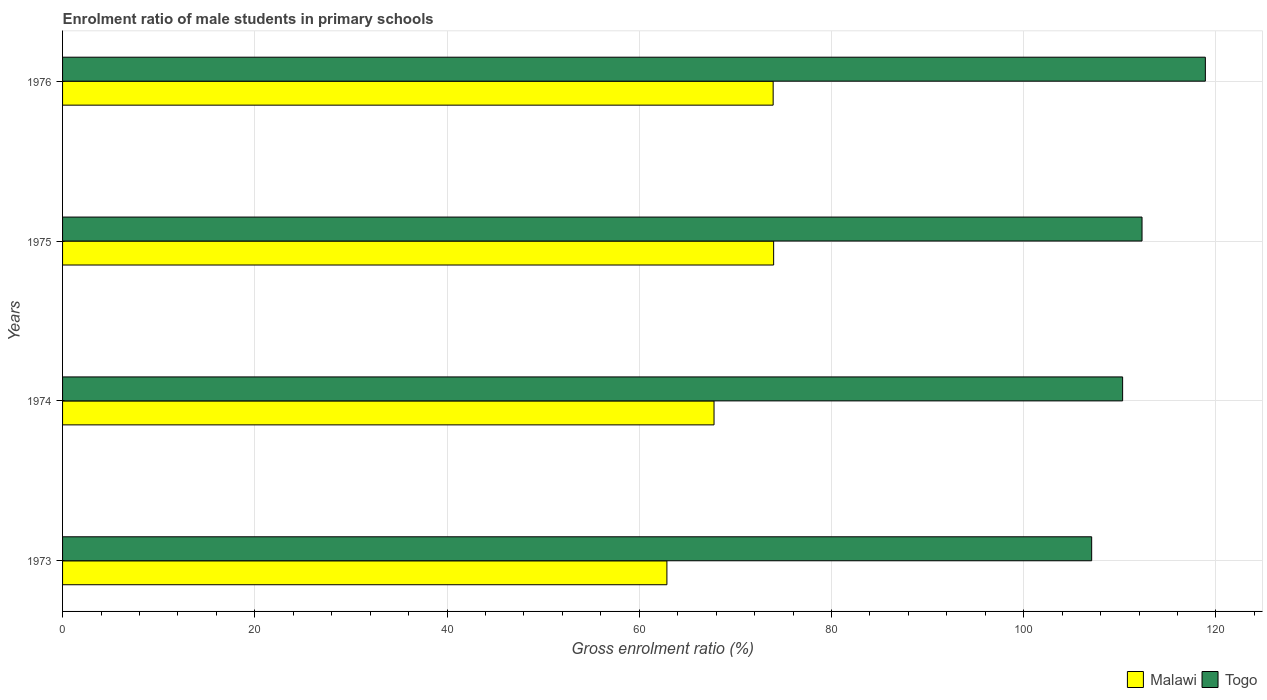Are the number of bars per tick equal to the number of legend labels?
Provide a succinct answer. Yes. Are the number of bars on each tick of the Y-axis equal?
Give a very brief answer. Yes. How many bars are there on the 2nd tick from the bottom?
Offer a very short reply. 2. In how many cases, is the number of bars for a given year not equal to the number of legend labels?
Ensure brevity in your answer.  0. What is the enrolment ratio of male students in primary schools in Malawi in 1975?
Your answer should be compact. 73.98. Across all years, what is the maximum enrolment ratio of male students in primary schools in Togo?
Make the answer very short. 118.9. Across all years, what is the minimum enrolment ratio of male students in primary schools in Malawi?
Your answer should be very brief. 62.88. In which year was the enrolment ratio of male students in primary schools in Malawi maximum?
Offer a very short reply. 1975. What is the total enrolment ratio of male students in primary schools in Togo in the graph?
Your answer should be very brief. 448.56. What is the difference between the enrolment ratio of male students in primary schools in Malawi in 1975 and that in 1976?
Provide a succinct answer. 0.05. What is the difference between the enrolment ratio of male students in primary schools in Togo in 1975 and the enrolment ratio of male students in primary schools in Malawi in 1974?
Offer a terse response. 44.53. What is the average enrolment ratio of male students in primary schools in Togo per year?
Give a very brief answer. 112.14. In the year 1973, what is the difference between the enrolment ratio of male students in primary schools in Togo and enrolment ratio of male students in primary schools in Malawi?
Keep it short and to the point. 44.19. In how many years, is the enrolment ratio of male students in primary schools in Malawi greater than 52 %?
Ensure brevity in your answer.  4. What is the ratio of the enrolment ratio of male students in primary schools in Togo in 1974 to that in 1976?
Offer a terse response. 0.93. Is the enrolment ratio of male students in primary schools in Malawi in 1973 less than that in 1974?
Provide a succinct answer. Yes. Is the difference between the enrolment ratio of male students in primary schools in Togo in 1973 and 1976 greater than the difference between the enrolment ratio of male students in primary schools in Malawi in 1973 and 1976?
Your answer should be compact. No. What is the difference between the highest and the second highest enrolment ratio of male students in primary schools in Malawi?
Offer a very short reply. 0.05. What is the difference between the highest and the lowest enrolment ratio of male students in primary schools in Malawi?
Your answer should be very brief. 11.11. Is the sum of the enrolment ratio of male students in primary schools in Togo in 1973 and 1975 greater than the maximum enrolment ratio of male students in primary schools in Malawi across all years?
Your answer should be very brief. Yes. What does the 2nd bar from the top in 1974 represents?
Provide a short and direct response. Malawi. What does the 1st bar from the bottom in 1976 represents?
Provide a short and direct response. Malawi. How many years are there in the graph?
Offer a terse response. 4. What is the difference between two consecutive major ticks on the X-axis?
Your answer should be very brief. 20. How are the legend labels stacked?
Offer a terse response. Horizontal. What is the title of the graph?
Keep it short and to the point. Enrolment ratio of male students in primary schools. What is the Gross enrolment ratio (%) of Malawi in 1973?
Ensure brevity in your answer.  62.88. What is the Gross enrolment ratio (%) in Togo in 1973?
Ensure brevity in your answer.  107.07. What is the Gross enrolment ratio (%) in Malawi in 1974?
Provide a short and direct response. 67.78. What is the Gross enrolment ratio (%) of Togo in 1974?
Offer a terse response. 110.29. What is the Gross enrolment ratio (%) in Malawi in 1975?
Keep it short and to the point. 73.98. What is the Gross enrolment ratio (%) of Togo in 1975?
Your answer should be very brief. 112.31. What is the Gross enrolment ratio (%) of Malawi in 1976?
Make the answer very short. 73.93. What is the Gross enrolment ratio (%) of Togo in 1976?
Make the answer very short. 118.9. Across all years, what is the maximum Gross enrolment ratio (%) of Malawi?
Provide a short and direct response. 73.98. Across all years, what is the maximum Gross enrolment ratio (%) of Togo?
Make the answer very short. 118.9. Across all years, what is the minimum Gross enrolment ratio (%) of Malawi?
Make the answer very short. 62.88. Across all years, what is the minimum Gross enrolment ratio (%) of Togo?
Keep it short and to the point. 107.07. What is the total Gross enrolment ratio (%) in Malawi in the graph?
Ensure brevity in your answer.  278.56. What is the total Gross enrolment ratio (%) of Togo in the graph?
Provide a succinct answer. 448.56. What is the difference between the Gross enrolment ratio (%) in Malawi in 1973 and that in 1974?
Offer a terse response. -4.9. What is the difference between the Gross enrolment ratio (%) in Togo in 1973 and that in 1974?
Provide a short and direct response. -3.22. What is the difference between the Gross enrolment ratio (%) of Malawi in 1973 and that in 1975?
Your answer should be very brief. -11.11. What is the difference between the Gross enrolment ratio (%) in Togo in 1973 and that in 1975?
Your answer should be very brief. -5.24. What is the difference between the Gross enrolment ratio (%) in Malawi in 1973 and that in 1976?
Offer a very short reply. -11.05. What is the difference between the Gross enrolment ratio (%) in Togo in 1973 and that in 1976?
Give a very brief answer. -11.83. What is the difference between the Gross enrolment ratio (%) in Malawi in 1974 and that in 1975?
Your response must be concise. -6.2. What is the difference between the Gross enrolment ratio (%) of Togo in 1974 and that in 1975?
Provide a short and direct response. -2.02. What is the difference between the Gross enrolment ratio (%) in Malawi in 1974 and that in 1976?
Make the answer very short. -6.15. What is the difference between the Gross enrolment ratio (%) of Togo in 1974 and that in 1976?
Provide a succinct answer. -8.61. What is the difference between the Gross enrolment ratio (%) of Malawi in 1975 and that in 1976?
Your answer should be compact. 0.05. What is the difference between the Gross enrolment ratio (%) in Togo in 1975 and that in 1976?
Offer a very short reply. -6.59. What is the difference between the Gross enrolment ratio (%) in Malawi in 1973 and the Gross enrolment ratio (%) in Togo in 1974?
Make the answer very short. -47.41. What is the difference between the Gross enrolment ratio (%) of Malawi in 1973 and the Gross enrolment ratio (%) of Togo in 1975?
Make the answer very short. -49.43. What is the difference between the Gross enrolment ratio (%) in Malawi in 1973 and the Gross enrolment ratio (%) in Togo in 1976?
Give a very brief answer. -56.02. What is the difference between the Gross enrolment ratio (%) of Malawi in 1974 and the Gross enrolment ratio (%) of Togo in 1975?
Provide a short and direct response. -44.53. What is the difference between the Gross enrolment ratio (%) in Malawi in 1974 and the Gross enrolment ratio (%) in Togo in 1976?
Keep it short and to the point. -51.12. What is the difference between the Gross enrolment ratio (%) of Malawi in 1975 and the Gross enrolment ratio (%) of Togo in 1976?
Your answer should be very brief. -44.91. What is the average Gross enrolment ratio (%) in Malawi per year?
Give a very brief answer. 69.64. What is the average Gross enrolment ratio (%) of Togo per year?
Your answer should be compact. 112.14. In the year 1973, what is the difference between the Gross enrolment ratio (%) in Malawi and Gross enrolment ratio (%) in Togo?
Keep it short and to the point. -44.19. In the year 1974, what is the difference between the Gross enrolment ratio (%) in Malawi and Gross enrolment ratio (%) in Togo?
Your answer should be compact. -42.51. In the year 1975, what is the difference between the Gross enrolment ratio (%) of Malawi and Gross enrolment ratio (%) of Togo?
Offer a very short reply. -38.33. In the year 1976, what is the difference between the Gross enrolment ratio (%) of Malawi and Gross enrolment ratio (%) of Togo?
Give a very brief answer. -44.97. What is the ratio of the Gross enrolment ratio (%) of Malawi in 1973 to that in 1974?
Your answer should be very brief. 0.93. What is the ratio of the Gross enrolment ratio (%) in Togo in 1973 to that in 1974?
Make the answer very short. 0.97. What is the ratio of the Gross enrolment ratio (%) of Malawi in 1973 to that in 1975?
Ensure brevity in your answer.  0.85. What is the ratio of the Gross enrolment ratio (%) in Togo in 1973 to that in 1975?
Provide a short and direct response. 0.95. What is the ratio of the Gross enrolment ratio (%) in Malawi in 1973 to that in 1976?
Your response must be concise. 0.85. What is the ratio of the Gross enrolment ratio (%) in Togo in 1973 to that in 1976?
Keep it short and to the point. 0.9. What is the ratio of the Gross enrolment ratio (%) of Malawi in 1974 to that in 1975?
Offer a terse response. 0.92. What is the ratio of the Gross enrolment ratio (%) in Togo in 1974 to that in 1975?
Offer a terse response. 0.98. What is the ratio of the Gross enrolment ratio (%) in Malawi in 1974 to that in 1976?
Make the answer very short. 0.92. What is the ratio of the Gross enrolment ratio (%) in Togo in 1974 to that in 1976?
Ensure brevity in your answer.  0.93. What is the ratio of the Gross enrolment ratio (%) of Malawi in 1975 to that in 1976?
Provide a short and direct response. 1. What is the ratio of the Gross enrolment ratio (%) in Togo in 1975 to that in 1976?
Make the answer very short. 0.94. What is the difference between the highest and the second highest Gross enrolment ratio (%) in Malawi?
Your response must be concise. 0.05. What is the difference between the highest and the second highest Gross enrolment ratio (%) in Togo?
Your answer should be very brief. 6.59. What is the difference between the highest and the lowest Gross enrolment ratio (%) in Malawi?
Provide a short and direct response. 11.11. What is the difference between the highest and the lowest Gross enrolment ratio (%) in Togo?
Your response must be concise. 11.83. 